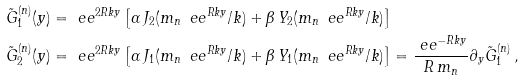Convert formula to latex. <formula><loc_0><loc_0><loc_500><loc_500>\tilde { G } ^ { ( n ) } _ { 1 } ( y ) & = \ e e ^ { 2 R k y } \left [ \alpha \, J _ { 2 } ( m _ { n } \, \ e e ^ { R k y } / k ) + \beta \, Y _ { 2 } ( m _ { n } \, \ e e ^ { R k y } / k ) \right ] \\ \tilde { G } ^ { ( n ) } _ { 2 } ( y ) & = \ e e ^ { 2 R k y } \left [ \alpha \, J _ { 1 } ( m _ { n } \, \ e e ^ { R k y } / k ) + \beta \, Y _ { 1 } ( m _ { n } \, \ e e ^ { R k y } / k ) \right ] = \frac { \ e e ^ { - R k y } } { R \, m _ { n } } \partial _ { y } \tilde { G } ^ { ( n ) } _ { 1 } \, ,</formula> 